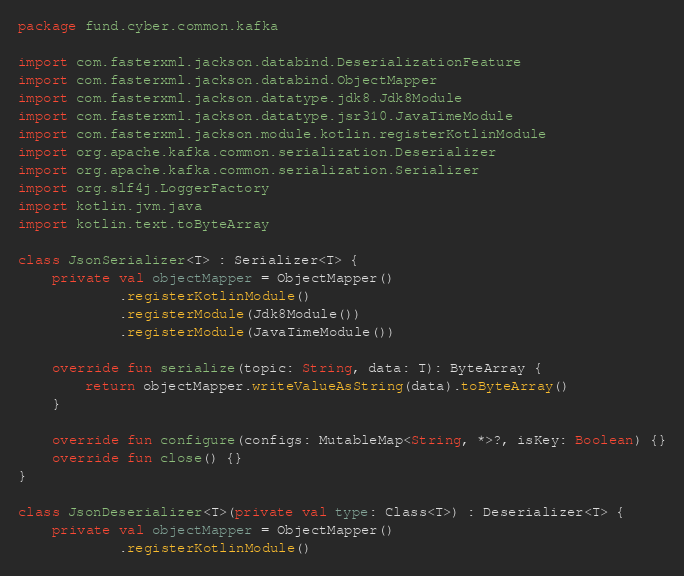Convert code to text. <code><loc_0><loc_0><loc_500><loc_500><_Kotlin_>package fund.cyber.common.kafka

import com.fasterxml.jackson.databind.DeserializationFeature
import com.fasterxml.jackson.databind.ObjectMapper
import com.fasterxml.jackson.datatype.jdk8.Jdk8Module
import com.fasterxml.jackson.datatype.jsr310.JavaTimeModule
import com.fasterxml.jackson.module.kotlin.registerKotlinModule
import org.apache.kafka.common.serialization.Deserializer
import org.apache.kafka.common.serialization.Serializer
import org.slf4j.LoggerFactory
import kotlin.jvm.java
import kotlin.text.toByteArray

class JsonSerializer<T> : Serializer<T> {
    private val objectMapper = ObjectMapper()
            .registerKotlinModule()
            .registerModule(Jdk8Module())
            .registerModule(JavaTimeModule())

    override fun serialize(topic: String, data: T): ByteArray {
        return objectMapper.writeValueAsString(data).toByteArray()
    }

    override fun configure(configs: MutableMap<String, *>?, isKey: Boolean) {}
    override fun close() {}
}

class JsonDeserializer<T>(private val type: Class<T>) : Deserializer<T> {
    private val objectMapper = ObjectMapper()
            .registerKotlinModule()</code> 